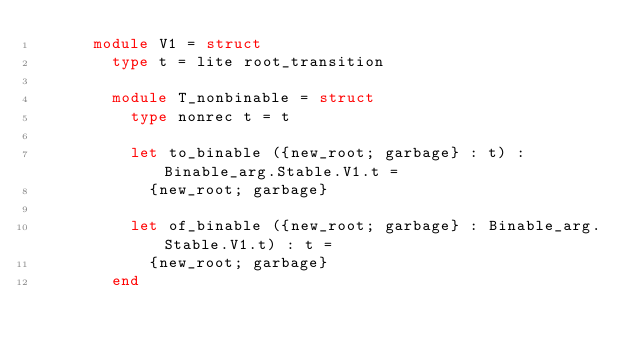<code> <loc_0><loc_0><loc_500><loc_500><_OCaml_>      module V1 = struct
        type t = lite root_transition

        module T_nonbinable = struct
          type nonrec t = t

          let to_binable ({new_root; garbage} : t) : Binable_arg.Stable.V1.t =
            {new_root; garbage}

          let of_binable ({new_root; garbage} : Binable_arg.Stable.V1.t) : t =
            {new_root; garbage}
        end
</code> 